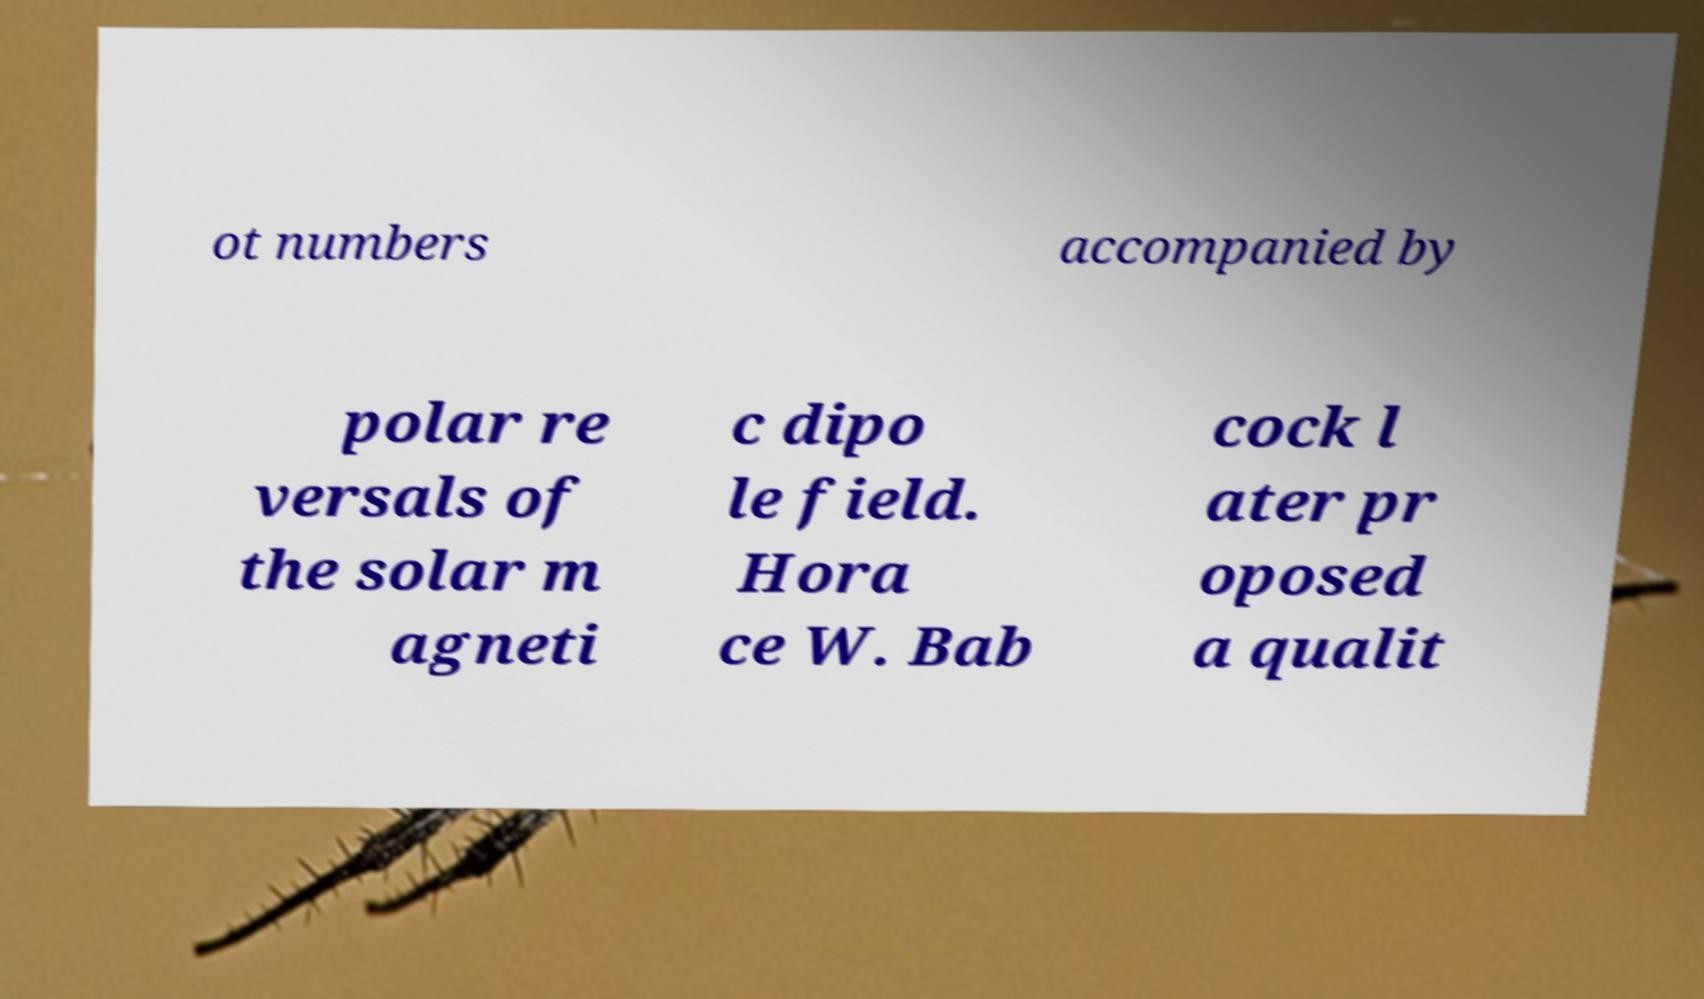Can you accurately transcribe the text from the provided image for me? ot numbers accompanied by polar re versals of the solar m agneti c dipo le field. Hora ce W. Bab cock l ater pr oposed a qualit 